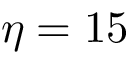Convert formula to latex. <formula><loc_0><loc_0><loc_500><loc_500>\eta = 1 5</formula> 